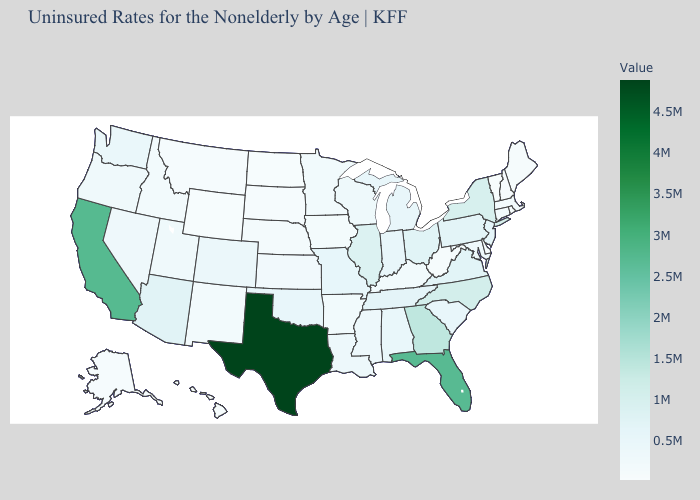Does the map have missing data?
Be succinct. No. Among the states that border Vermont , does Massachusetts have the highest value?
Give a very brief answer. No. Is the legend a continuous bar?
Keep it brief. Yes. Does the map have missing data?
Concise answer only. No. 